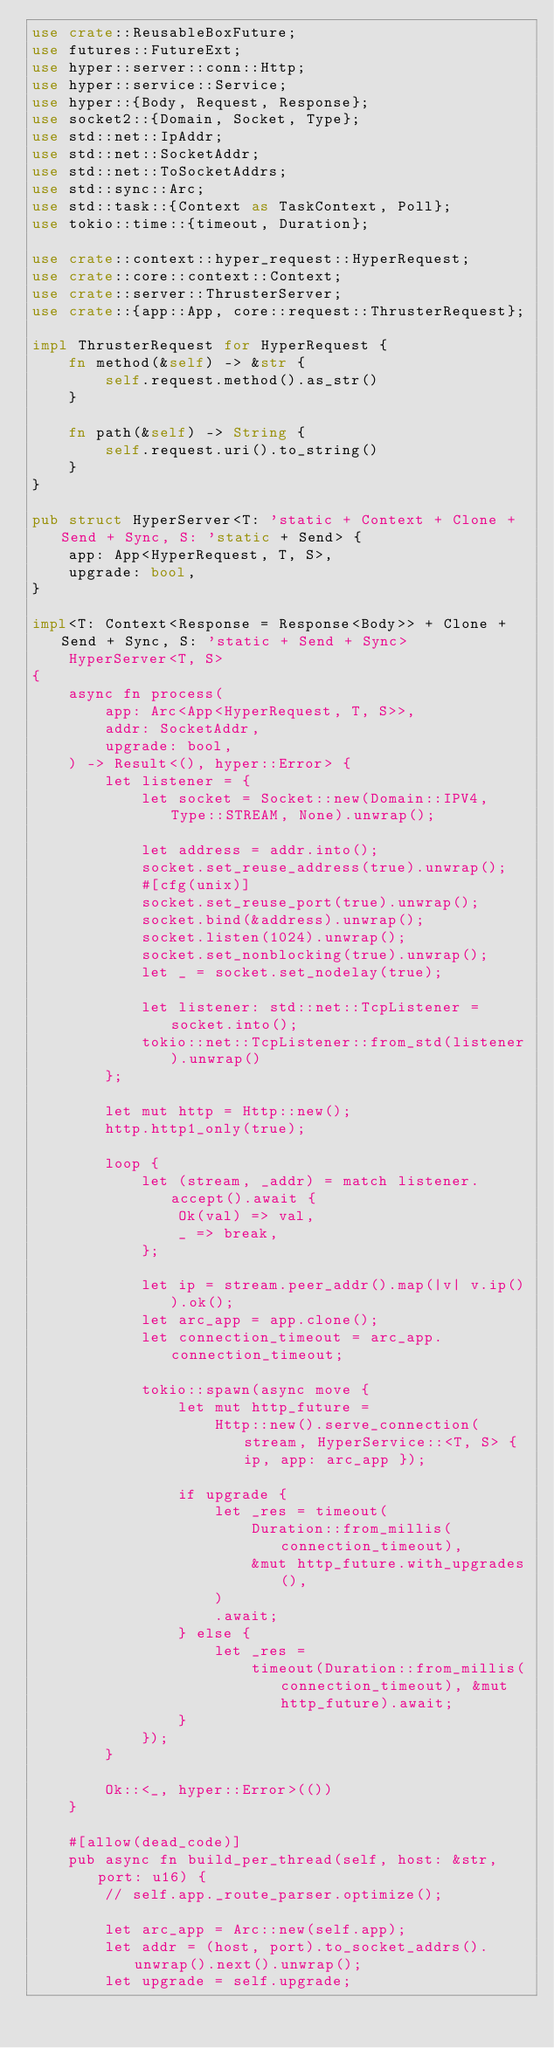<code> <loc_0><loc_0><loc_500><loc_500><_Rust_>use crate::ReusableBoxFuture;
use futures::FutureExt;
use hyper::server::conn::Http;
use hyper::service::Service;
use hyper::{Body, Request, Response};
use socket2::{Domain, Socket, Type};
use std::net::IpAddr;
use std::net::SocketAddr;
use std::net::ToSocketAddrs;
use std::sync::Arc;
use std::task::{Context as TaskContext, Poll};
use tokio::time::{timeout, Duration};

use crate::context::hyper_request::HyperRequest;
use crate::core::context::Context;
use crate::server::ThrusterServer;
use crate::{app::App, core::request::ThrusterRequest};

impl ThrusterRequest for HyperRequest {
    fn method(&self) -> &str {
        self.request.method().as_str()
    }

    fn path(&self) -> String {
        self.request.uri().to_string()
    }
}

pub struct HyperServer<T: 'static + Context + Clone + Send + Sync, S: 'static + Send> {
    app: App<HyperRequest, T, S>,
    upgrade: bool,
}

impl<T: Context<Response = Response<Body>> + Clone + Send + Sync, S: 'static + Send + Sync>
    HyperServer<T, S>
{
    async fn process(
        app: Arc<App<HyperRequest, T, S>>,
        addr: SocketAddr,
        upgrade: bool,
    ) -> Result<(), hyper::Error> {
        let listener = {
            let socket = Socket::new(Domain::IPV4, Type::STREAM, None).unwrap();

            let address = addr.into();
            socket.set_reuse_address(true).unwrap();
            #[cfg(unix)]
            socket.set_reuse_port(true).unwrap();
            socket.bind(&address).unwrap();
            socket.listen(1024).unwrap();
            socket.set_nonblocking(true).unwrap();
            let _ = socket.set_nodelay(true);

            let listener: std::net::TcpListener = socket.into();
            tokio::net::TcpListener::from_std(listener).unwrap()
        };

        let mut http = Http::new();
        http.http1_only(true);

        loop {
            let (stream, _addr) = match listener.accept().await {
                Ok(val) => val,
                _ => break,
            };

            let ip = stream.peer_addr().map(|v| v.ip()).ok();
            let arc_app = app.clone();
            let connection_timeout = arc_app.connection_timeout;

            tokio::spawn(async move {
                let mut http_future =
                    Http::new().serve_connection(stream, HyperService::<T, S> { ip, app: arc_app });

                if upgrade {
                    let _res = timeout(
                        Duration::from_millis(connection_timeout),
                        &mut http_future.with_upgrades(),
                    )
                    .await;
                } else {
                    let _res =
                        timeout(Duration::from_millis(connection_timeout), &mut http_future).await;
                }
            });
        }

        Ok::<_, hyper::Error>(())
    }

    #[allow(dead_code)]
    pub async fn build_per_thread(self, host: &str, port: u16) {
        // self.app._route_parser.optimize();

        let arc_app = Arc::new(self.app);
        let addr = (host, port).to_socket_addrs().unwrap().next().unwrap();
        let upgrade = self.upgrade;
</code> 